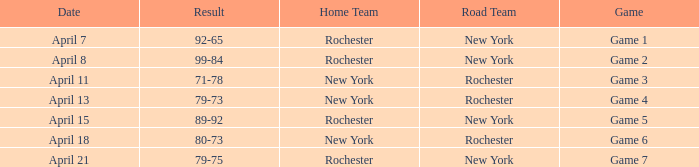Write the full table. {'header': ['Date', 'Result', 'Home Team', 'Road Team', 'Game'], 'rows': [['April 7', '92-65', 'Rochester', 'New York', 'Game 1'], ['April 8', '99-84', 'Rochester', 'New York', 'Game 2'], ['April 11', '71-78', 'New York', 'Rochester', 'Game 3'], ['April 13', '79-73', 'New York', 'Rochester', 'Game 4'], ['April 15', '89-92', 'Rochester', 'New York', 'Game 5'], ['April 18', '80-73', 'New York', 'Rochester', 'Game 6'], ['April 21', '79-75', 'Rochester', 'New York', 'Game 7']]} Which Date has a Road Team of new york, and a Result of 79-75? April 21. 